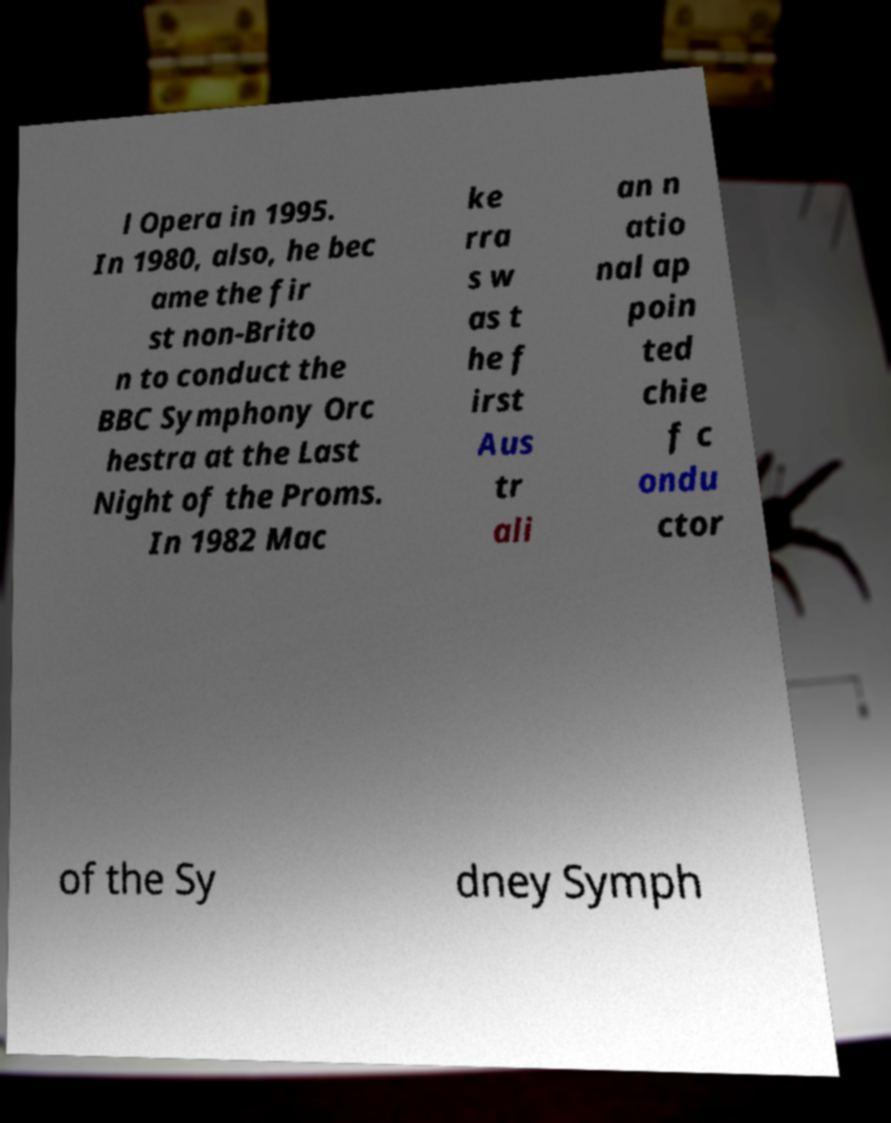Could you extract and type out the text from this image? l Opera in 1995. In 1980, also, he bec ame the fir st non-Brito n to conduct the BBC Symphony Orc hestra at the Last Night of the Proms. In 1982 Mac ke rra s w as t he f irst Aus tr ali an n atio nal ap poin ted chie f c ondu ctor of the Sy dney Symph 